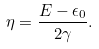Convert formula to latex. <formula><loc_0><loc_0><loc_500><loc_500>\eta = \frac { E - \epsilon _ { 0 } } { 2 \gamma } .</formula> 